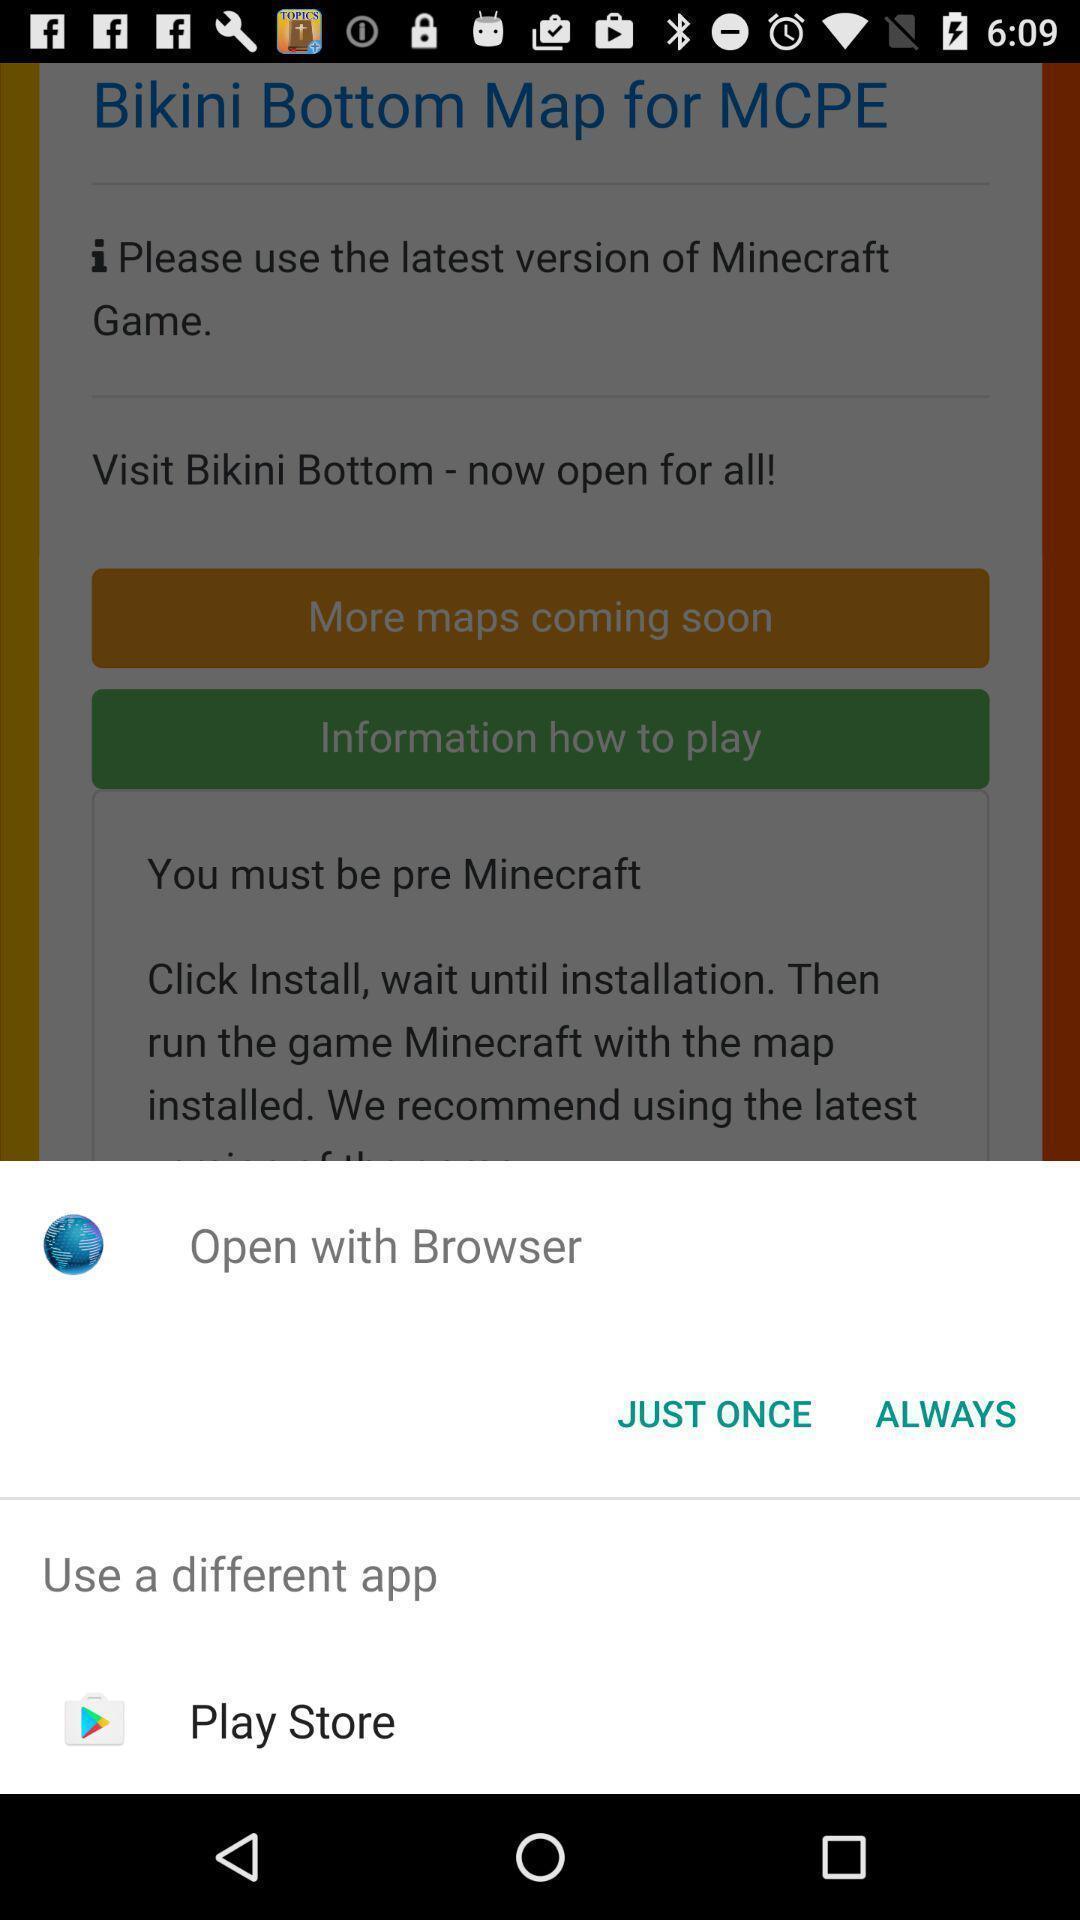Provide a textual representation of this image. Popup to open for the gaming app. 